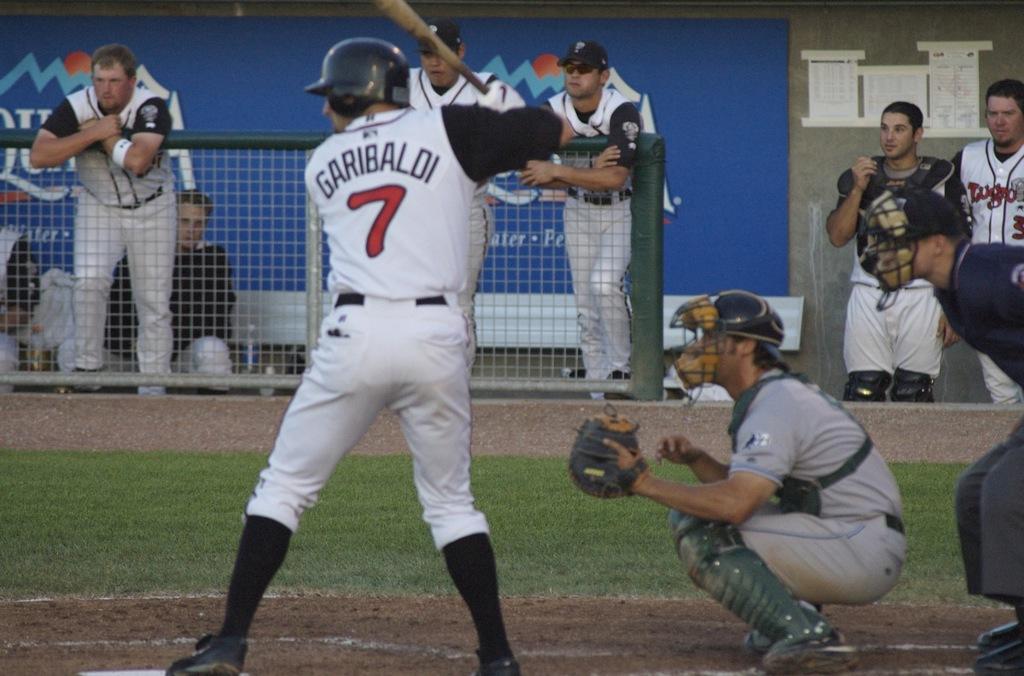What is the number on the batters back?
Offer a very short reply. 7. What is the name written across the back of the batters shirt?
Give a very brief answer. Garibaldi. 